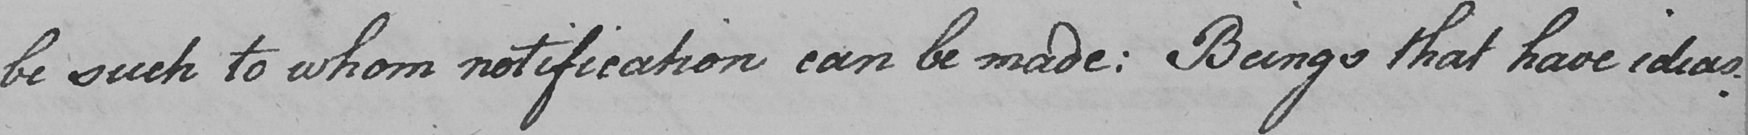Can you tell me what this handwritten text says? be such to whom notification can be made :  Beings that have ideas : 